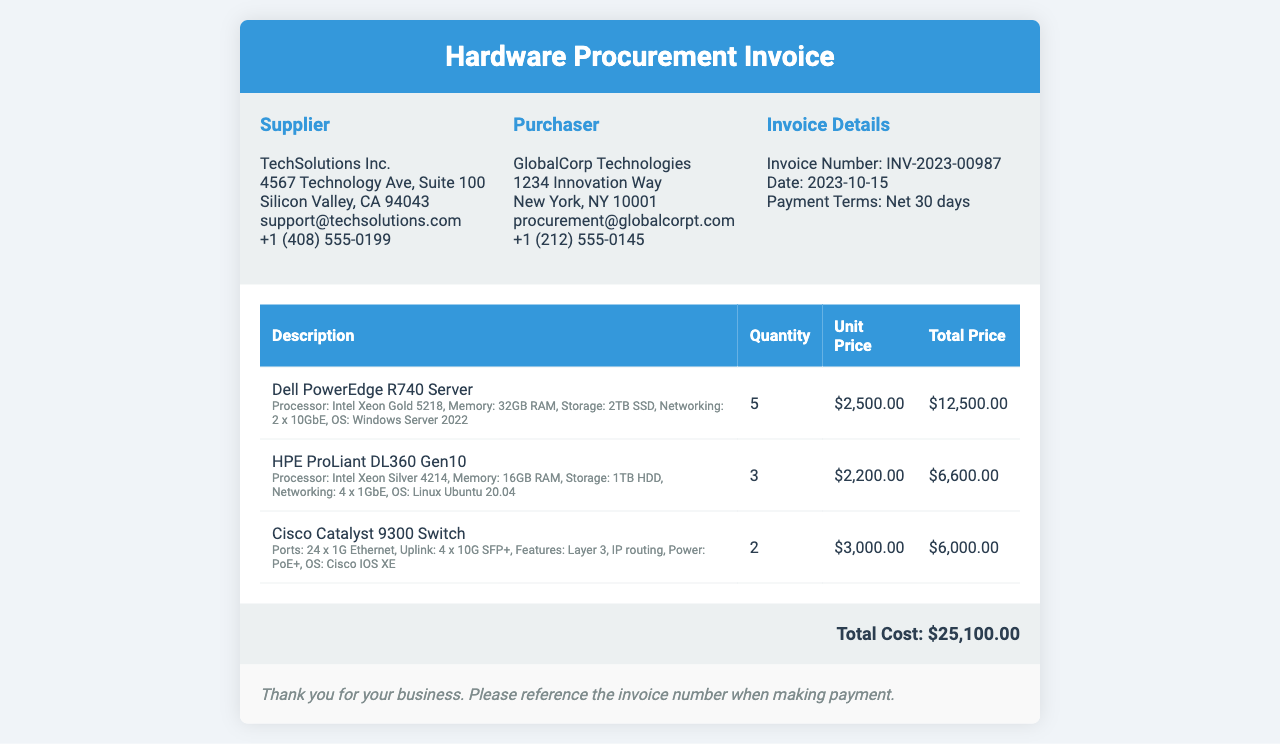What is the invoice number? The invoice number is mentioned under "Invoice Details" in the document.
Answer: INV-2023-00987 What is the total cost? The total cost is stated at the end of the invoice in the total section.
Answer: $25,100.00 Who is the supplier? The supplier details are provided in the top left section of the document.
Answer: TechSolutions Inc How many Dell PowerEdge R740 Servers were purchased? The quantity is specified in the itemized section of the invoice under the Dell PowerEdge R740 description.
Answer: 5 What is the payment term? The payment term is listed under "Invoice Details" in the document.
Answer: Net 30 days What operating system is installed on the HPE ProLiant DL360 Gen10? The operating system for this item is included in the specifications provided in the itemized section.
Answer: Linux Ubuntu 20.04 What is the processing power of the Cisco Catalyst 9300 Switch? This information can be derived from the specifications in the itemized section of the document.
Answer: Layer 3 How many total servers were ordered? The total number of servers includes the quantities of the Dell PowerEdge and HPE ProLiant listed.
Answer: 8 What is the address of the purchaser? The address of the purchaser is detailed in the top right section of the document.
Answer: 1234 Innovation Way, New York, NY 10001 